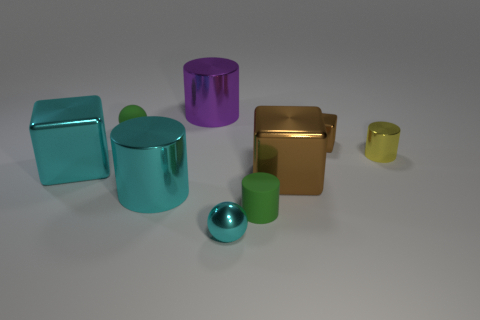Do the tiny sphere that is behind the small cyan thing and the big cyan object that is on the right side of the cyan block have the same material?
Keep it short and to the point. No. What number of rubber objects have the same shape as the tiny cyan metallic object?
Your response must be concise. 1. What number of large metal cubes have the same color as the tiny metal sphere?
Your answer should be very brief. 1. There is a matte thing on the left side of the purple cylinder; does it have the same shape as the tiny green thing that is in front of the yellow cylinder?
Offer a very short reply. No. There is a tiny green object on the left side of the rubber cylinder to the right of the small green rubber ball; what number of tiny brown cubes are to the right of it?
Ensure brevity in your answer.  1. What material is the tiny sphere that is in front of the large shiny block to the right of the green matte thing left of the purple thing?
Give a very brief answer. Metal. Is the material of the small cylinder that is behind the large brown metallic block the same as the cyan sphere?
Your answer should be very brief. Yes. What number of other matte cylinders are the same size as the green rubber cylinder?
Offer a terse response. 0. Are there more tiny spheres left of the large purple object than cyan things behind the cyan cylinder?
Ensure brevity in your answer.  No. Is there a brown matte thing that has the same shape as the big purple object?
Ensure brevity in your answer.  No. 